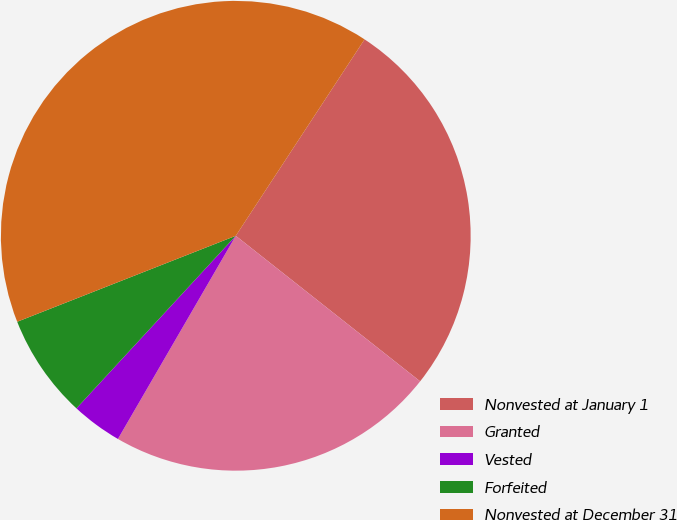<chart> <loc_0><loc_0><loc_500><loc_500><pie_chart><fcel>Nonvested at January 1<fcel>Granted<fcel>Vested<fcel>Forfeited<fcel>Nonvested at December 31<nl><fcel>26.4%<fcel>22.73%<fcel>3.5%<fcel>7.17%<fcel>40.2%<nl></chart> 